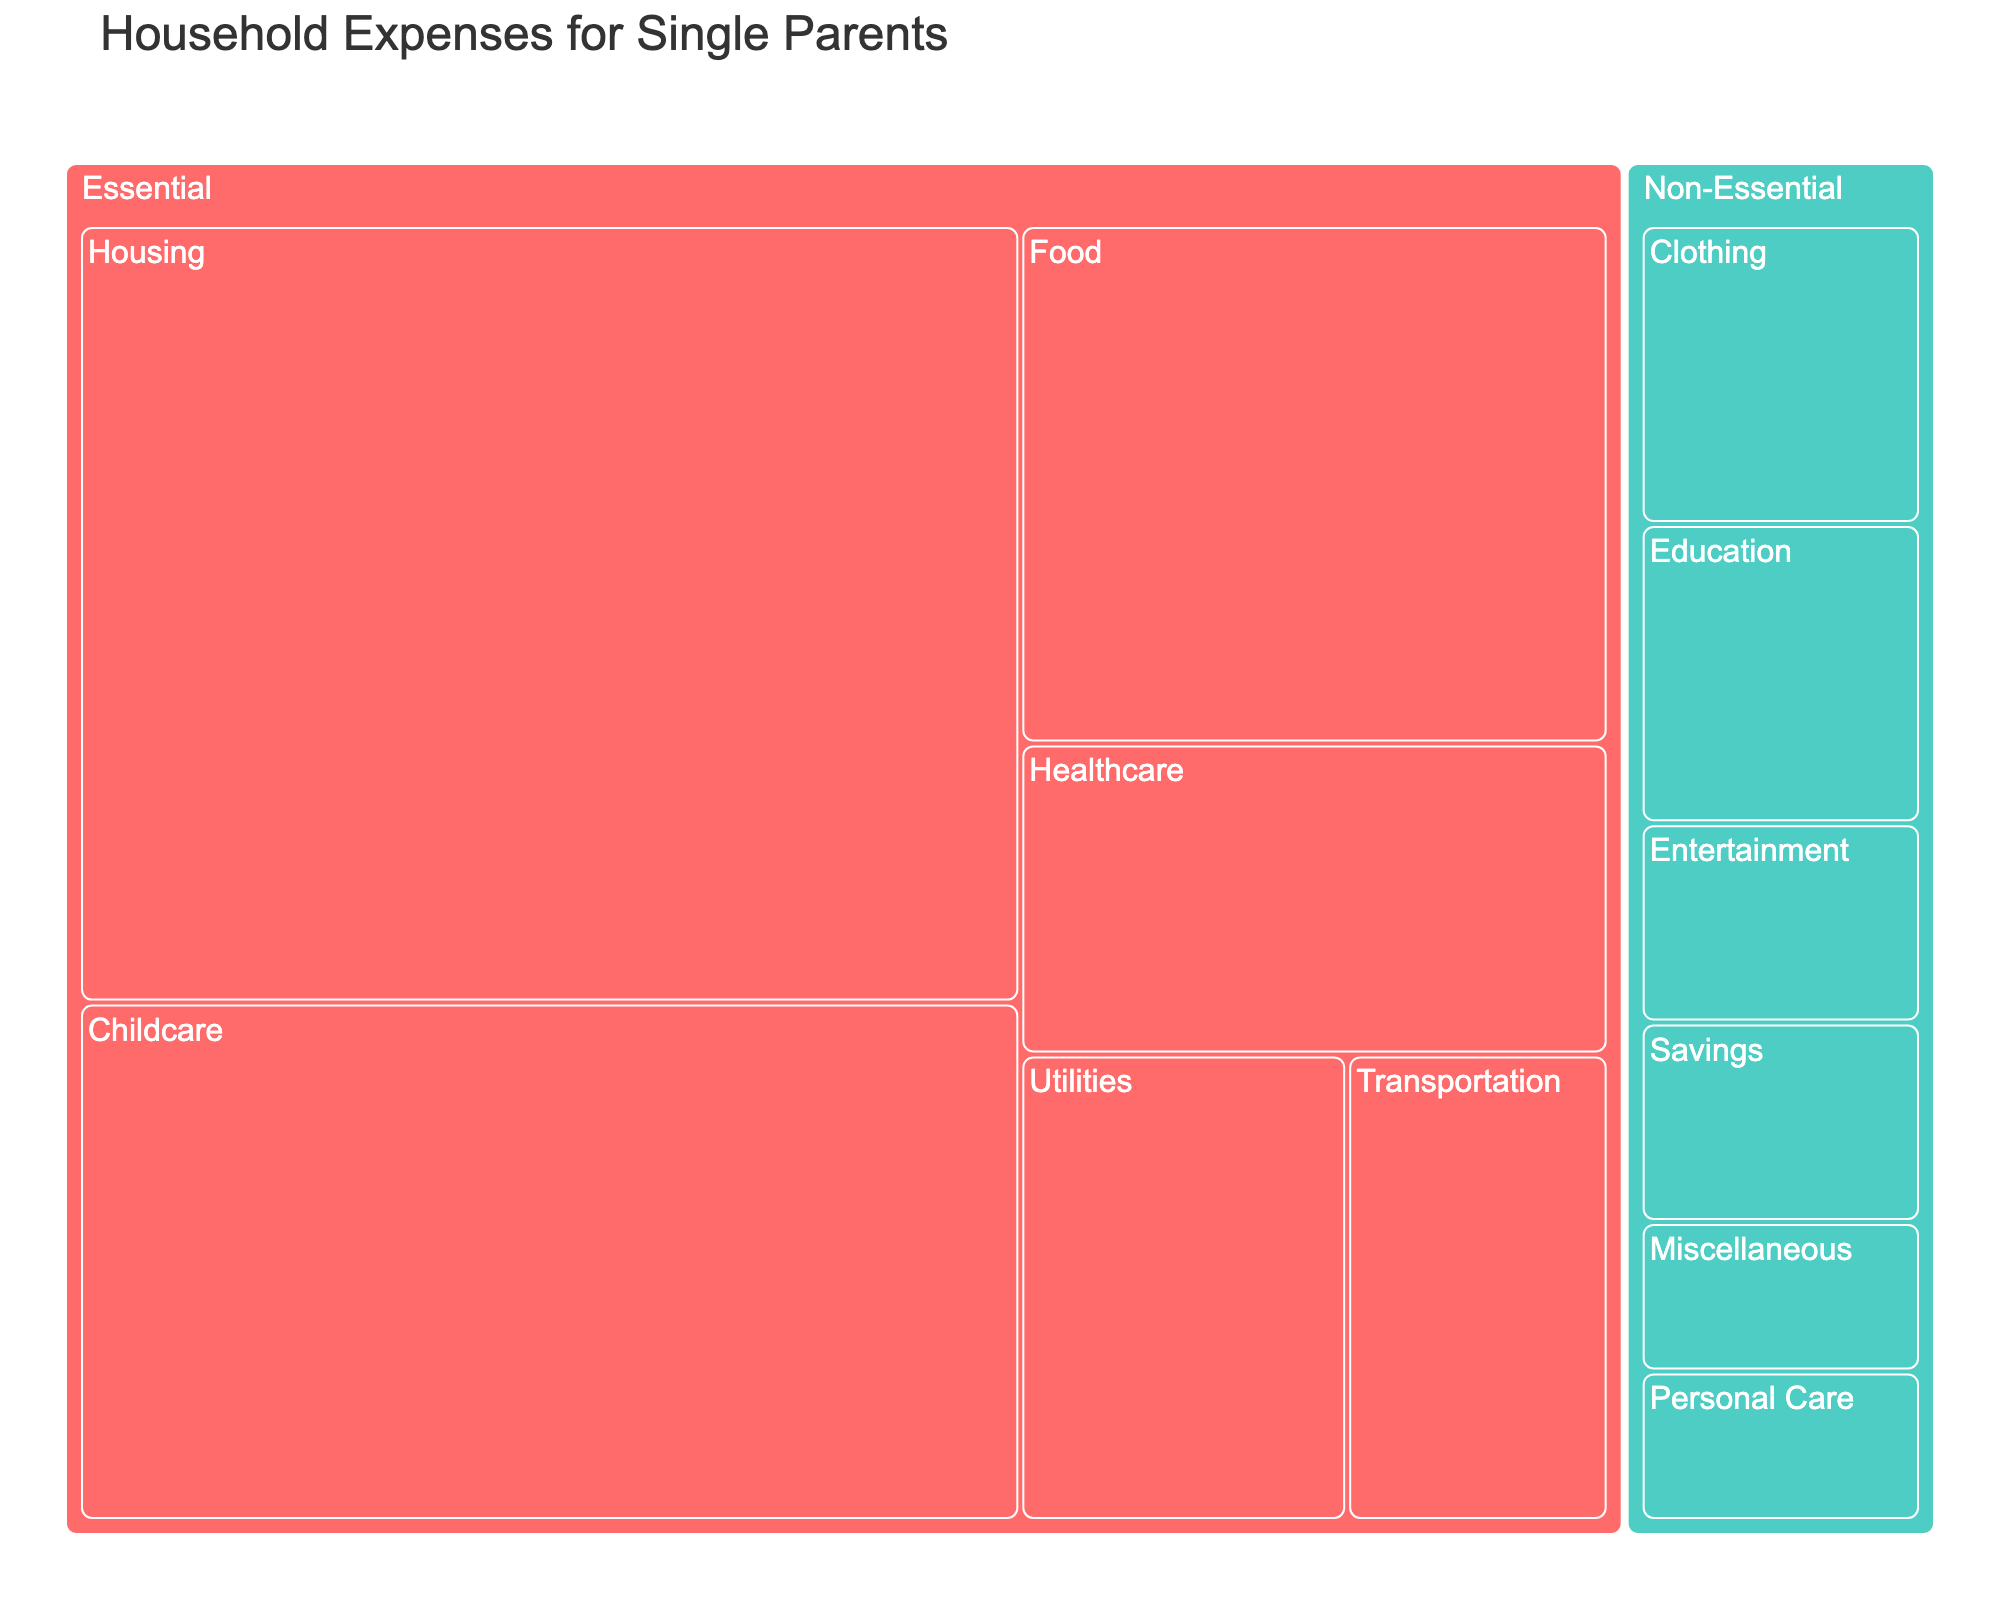What's the title of the figure? The title of the figure is prominently displayed at the top of the image. It provides a summary of what the data visualization represents.
Answer: Household Expenses for Single Parents Which category has the highest total expense? To find the category with the highest total expense, visually compare the sizes of the blocks representing the essential and non-essential categories. The larger block indicates the higher total expense. The essential costs category has more value boxes and larger areas overall.
Answer: Essential What is the total expense for Non-Essential costs? Sum up the values of all subcategories under the Non-Essential category: Entertainment (100) + Clothing (150) + Personal Care (75) + Education (150) + Savings (100) + Miscellaneous (75).
Answer: 650 Which subcategory under Essential costs has the highest expense? Look for the largest block within the Essential category. The subcategory with the largest size within this area visually represents the highest expense. Childcare, with a value of 800, has the largest block.
Answer: Childcare How much more expensive is Housing compared to Transportation? Subtract the value of Transportation from the value of Housing: 1200 (Housing) - 200 (Transportation) = 1000.
Answer: 1000 What percentage of the total Essential costs is allocated to Healthcare? Calculate the total Essential costs and then find the percentage allocated to Healthcare. Total Essential costs are calculated as Housing (1200) + Food (500) + Utilities (250) + Healthcare (300) + Childcare (800) + Transportation (200) = 3250. Then, the percentage for Healthcare is (300 / 3250) * 100 ≈ 9.23.
Answer: 9.23% Which subcategory under Non-Essential costs has the smallest expense? Identify the smallest block within the Non-Essential category. The subcategory with the smallest size represents the smallest expense. Personal Care and Miscellaneous have the smallest values of 75 each.
Answer: Personal Care and Miscellaneous Is the total expense on Non-Essential costs less than the total expense on Essential costs? Calculate the total expense for both categories and compare. Total Non-Essential costs are 650, and total Essential costs are 3250. The total Non-Essential costs are less than the total Essential costs.
Answer: Yes What is the ratio of Food expenses to Healthcare expenses? Divide the expense value of Food by the expense value of Healthcare: 500 (Food) / 300 (Healthcare) = 5/3 or approximately 1.67.
Answer: 1.67 